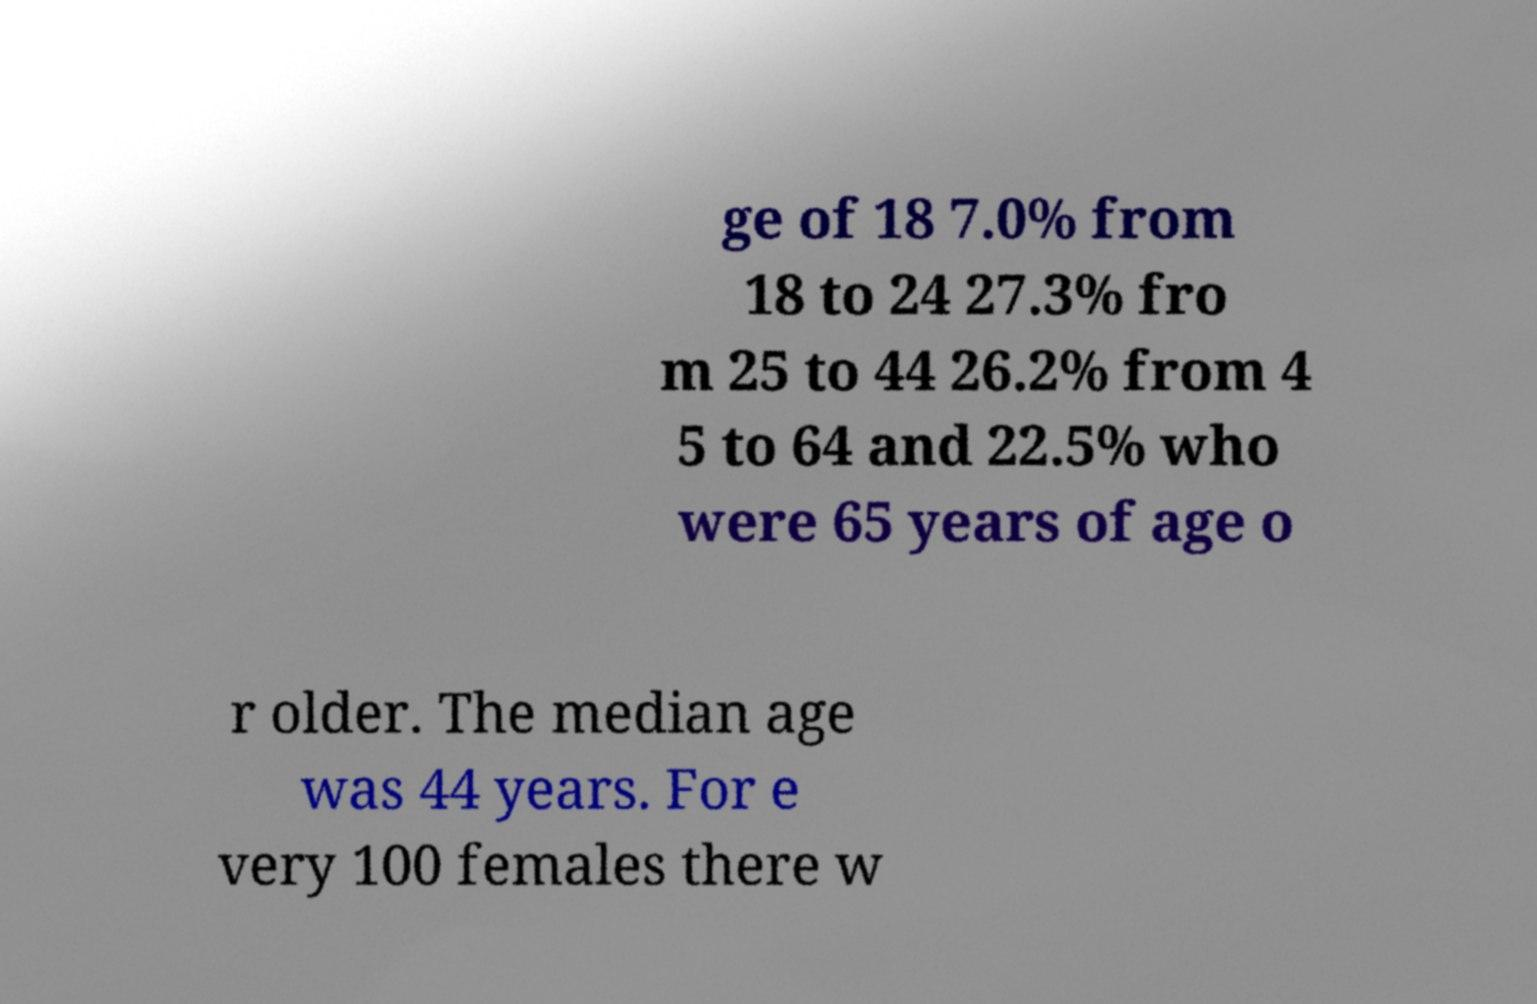I need the written content from this picture converted into text. Can you do that? ge of 18 7.0% from 18 to 24 27.3% fro m 25 to 44 26.2% from 4 5 to 64 and 22.5% who were 65 years of age o r older. The median age was 44 years. For e very 100 females there w 